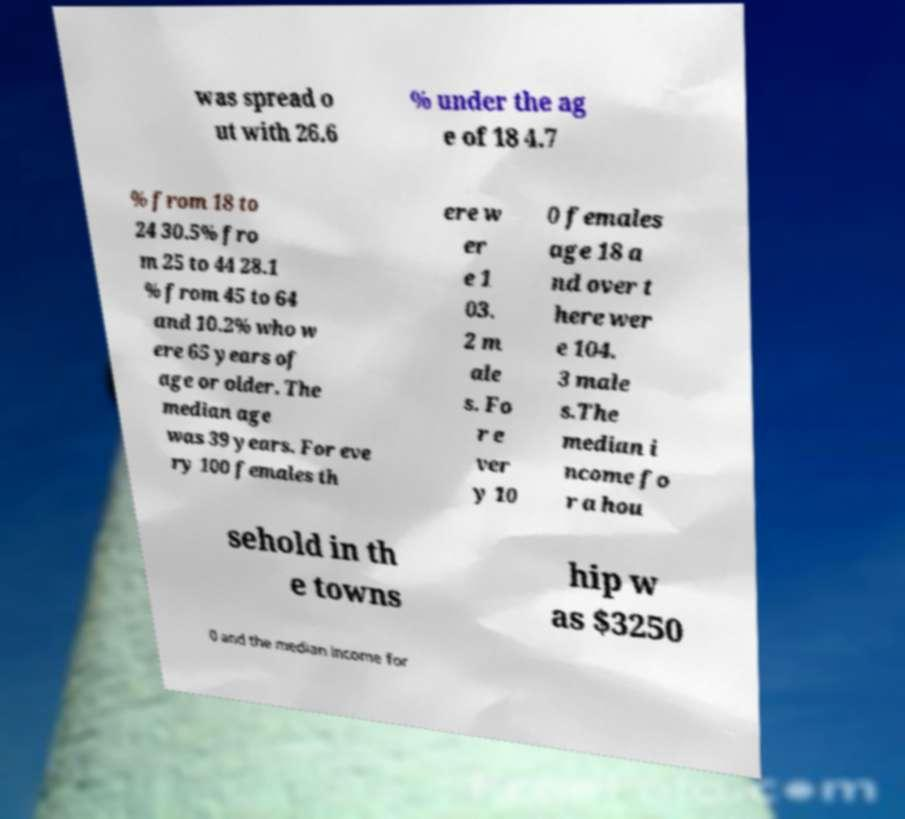I need the written content from this picture converted into text. Can you do that? was spread o ut with 26.6 % under the ag e of 18 4.7 % from 18 to 24 30.5% fro m 25 to 44 28.1 % from 45 to 64 and 10.2% who w ere 65 years of age or older. The median age was 39 years. For eve ry 100 females th ere w er e 1 03. 2 m ale s. Fo r e ver y 10 0 females age 18 a nd over t here wer e 104. 3 male s.The median i ncome fo r a hou sehold in th e towns hip w as $3250 0 and the median income for 